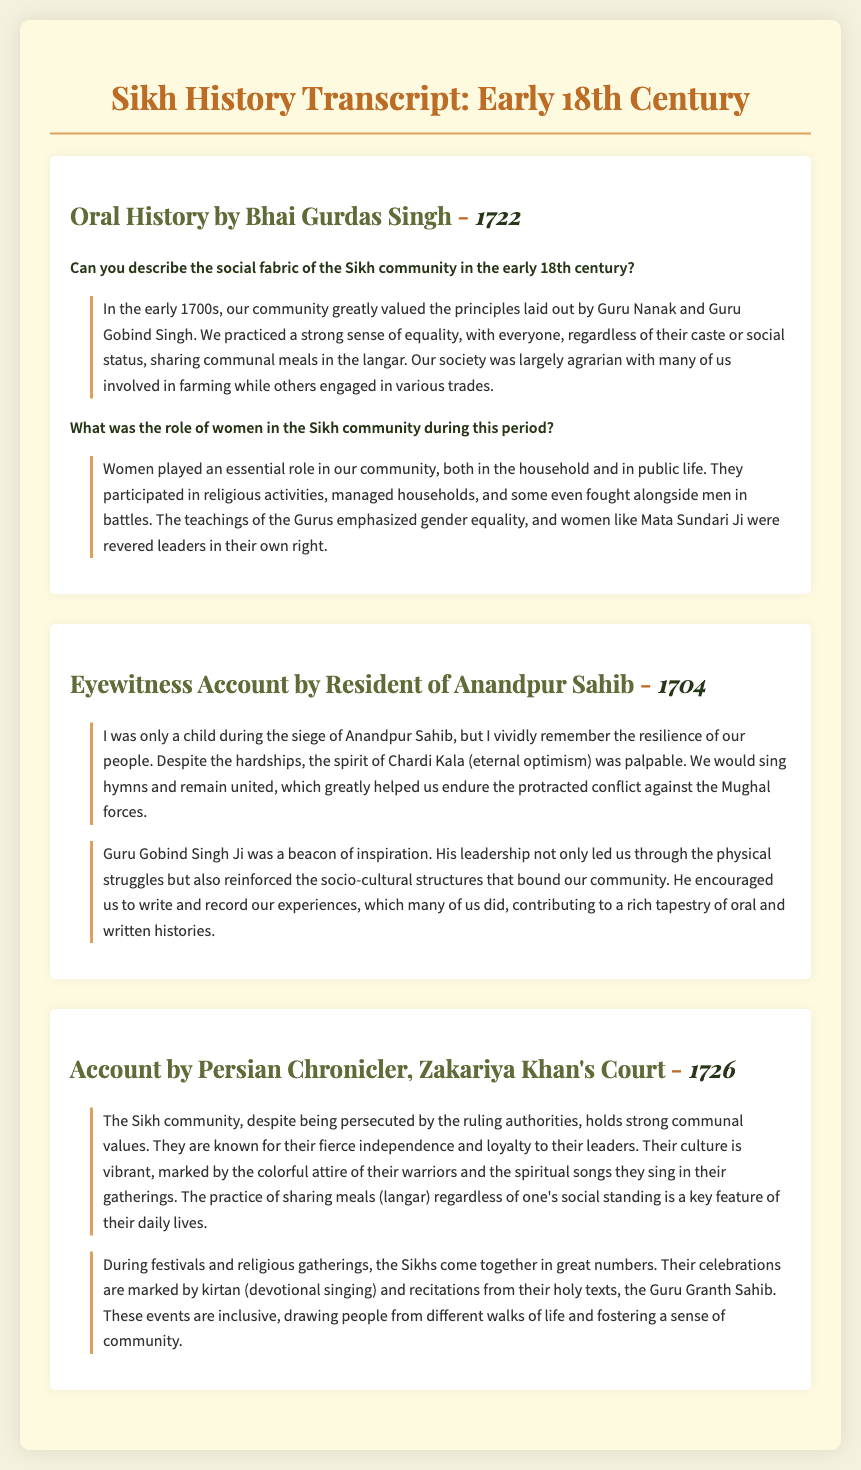What year was the oral history by Bhai Gurdas Singh recorded? The date provided in the document for Bhai Gurdas Singh's oral history is 1722.
Answer: 1722 What is the term mentioned that describes the Sikh spirit of eternal optimism? The document references the term "Chardi Kala" to describe the Sikh spirit of eternal optimism.
Answer: Chardi Kala Who was a revered leader in the Sikh community mentioned in the oral history? The oral history mentions Mata Sundari Ji as a revered leader in the Sikh community.
Answer: Mata Sundari Ji What communal practice is emphasized in the Sikh community according to the document? The document highlights the practice of "langar," which involves sharing meals regardless of social standing.
Answer: langar What significant event does the eyewitness account relate to regarding Anandpur Sahib? The eyewitness account discusses the "siege of Anandpur Sahib" as a significant event experienced by the narrator.
Answer: siege of Anandpur Sahib In what year was the account written by the Persian chronicler? The date noted in the document for the account by the Persian chronicler is 1726.
Answer: 1726 What form of expression is encouraged by Guru Gobind Singh Ji during struggles? The document indicates Guru Gobind Singh Ji encouraged writing and recording experiences as a means of expression.
Answer: writing and recording experiences What is a key feature of Sikh celebrations mentioned in the observations? The document mentions that Sikh celebrations are marked by "kirtan," which refers to devotional singing.
Answer: kirtan What social aspect is acknowledged in the observations by the Persian chronicler about the Sikh community? The observations highlight that the Sikh community holds "strong communal values" despite persecution.
Answer: strong communal values 